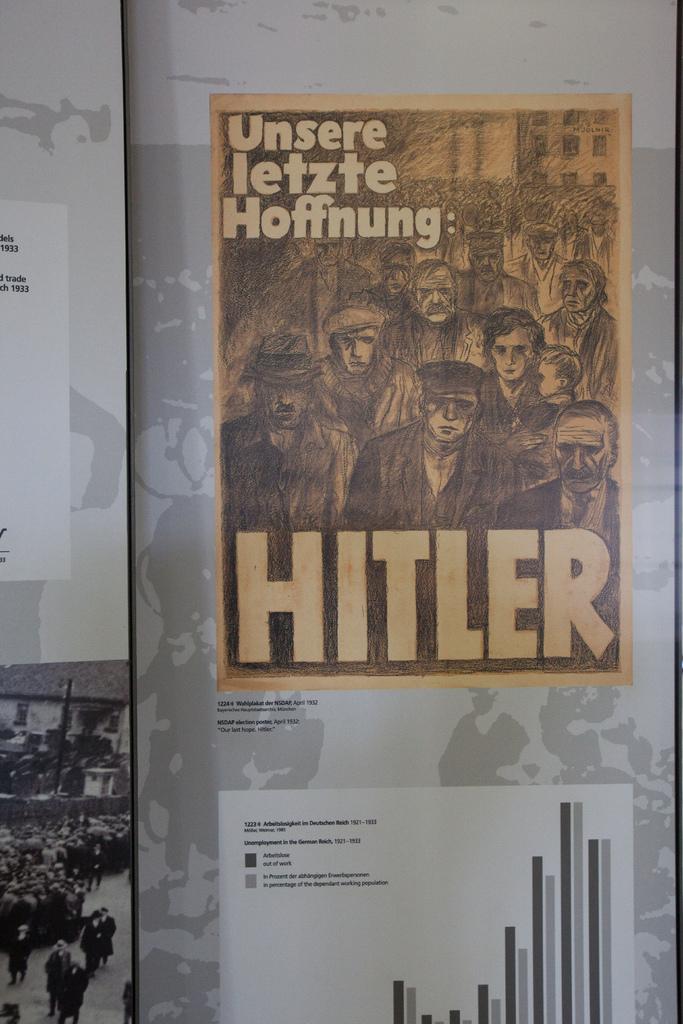What is the name of the person on the poster?
Offer a very short reply. Hitler. 